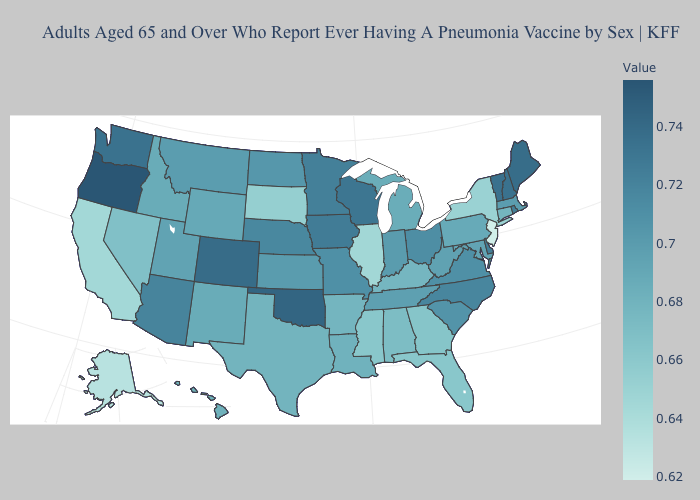Which states have the lowest value in the MidWest?
Be succinct. Illinois. Among the states that border North Carolina , does Georgia have the highest value?
Give a very brief answer. No. Among the states that border Kentucky , which have the highest value?
Keep it brief. Ohio. Does the map have missing data?
Be succinct. No. Does Oklahoma have the highest value in the South?
Concise answer only. Yes. Does North Dakota have a higher value than New Mexico?
Concise answer only. Yes. Among the states that border Kentucky , does Ohio have the highest value?
Answer briefly. Yes. 